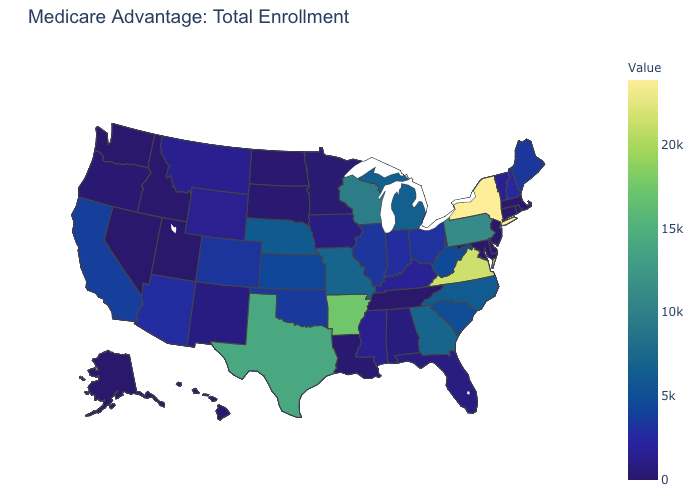Which states hav the highest value in the West?
Write a very short answer. California. Among the states that border New Mexico , which have the highest value?
Keep it brief. Texas. Which states have the lowest value in the MidWest?
Quick response, please. North Dakota. Which states have the lowest value in the USA?
Short answer required. Alaska, Connecticut, Delaware, Hawaii, Idaho, Massachusetts, Maryland, New Jersey, Nevada, Rhode Island, Tennessee, Utah, Washington. Among the states that border Illinois , which have the highest value?
Quick response, please. Wisconsin. Does Kentucky have the lowest value in the USA?
Quick response, please. No. 